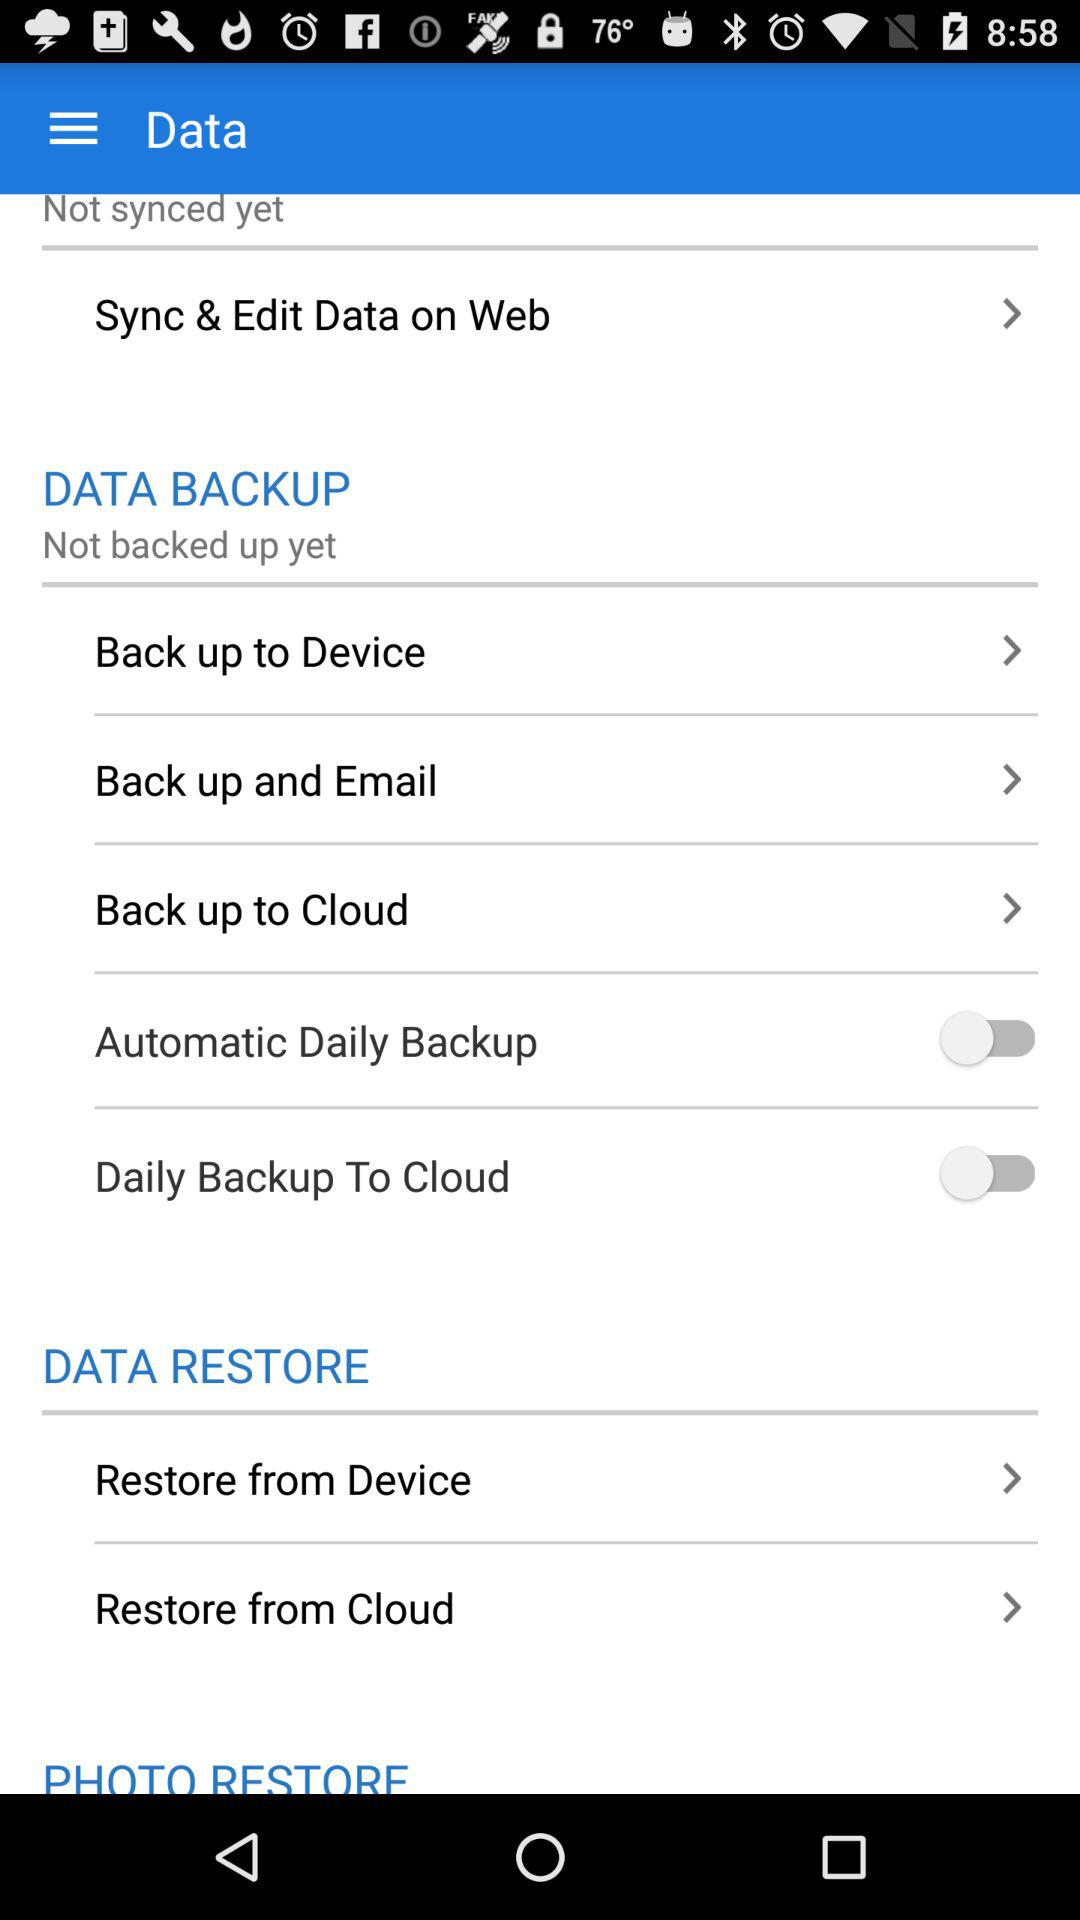How many items are in the Data Restore section?
Answer the question using a single word or phrase. 2 